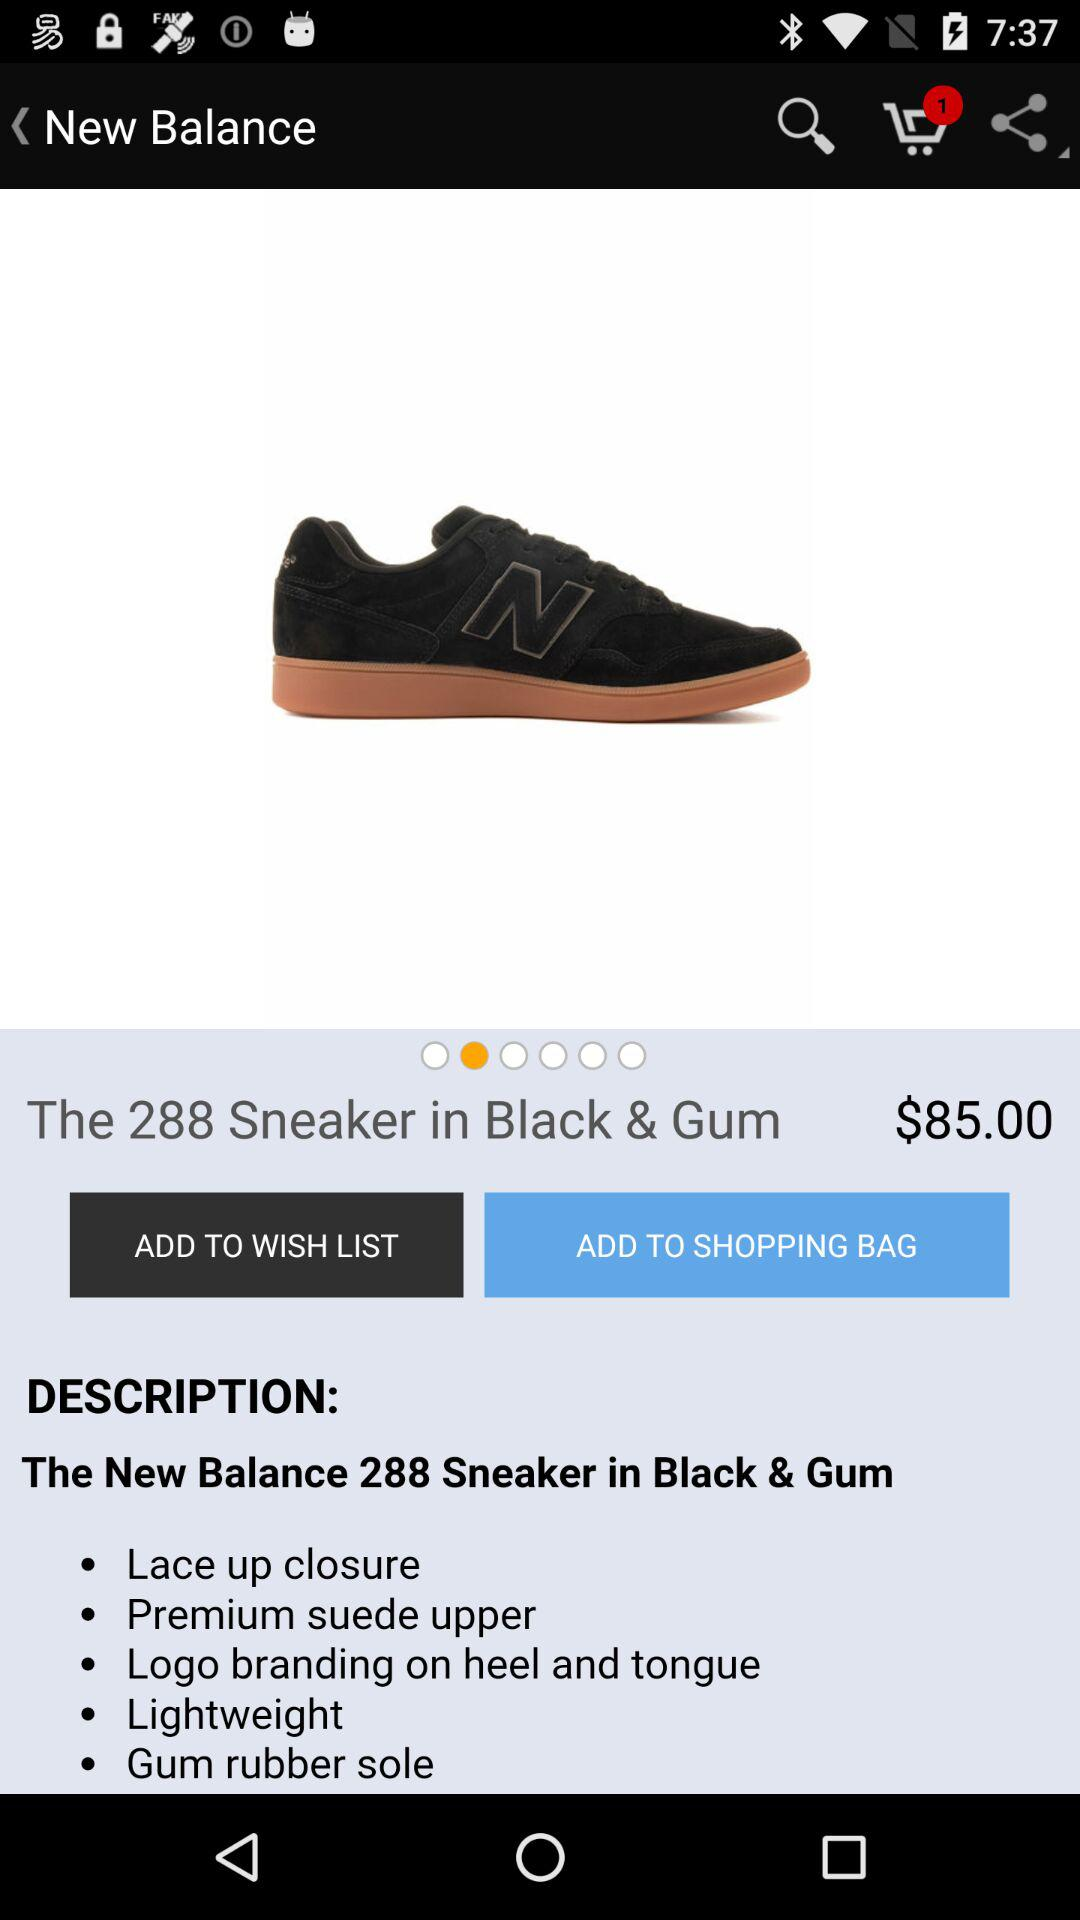How many more dollars is the price of the product than the number of items in the shopping cart?
Answer the question using a single word or phrase. 84 